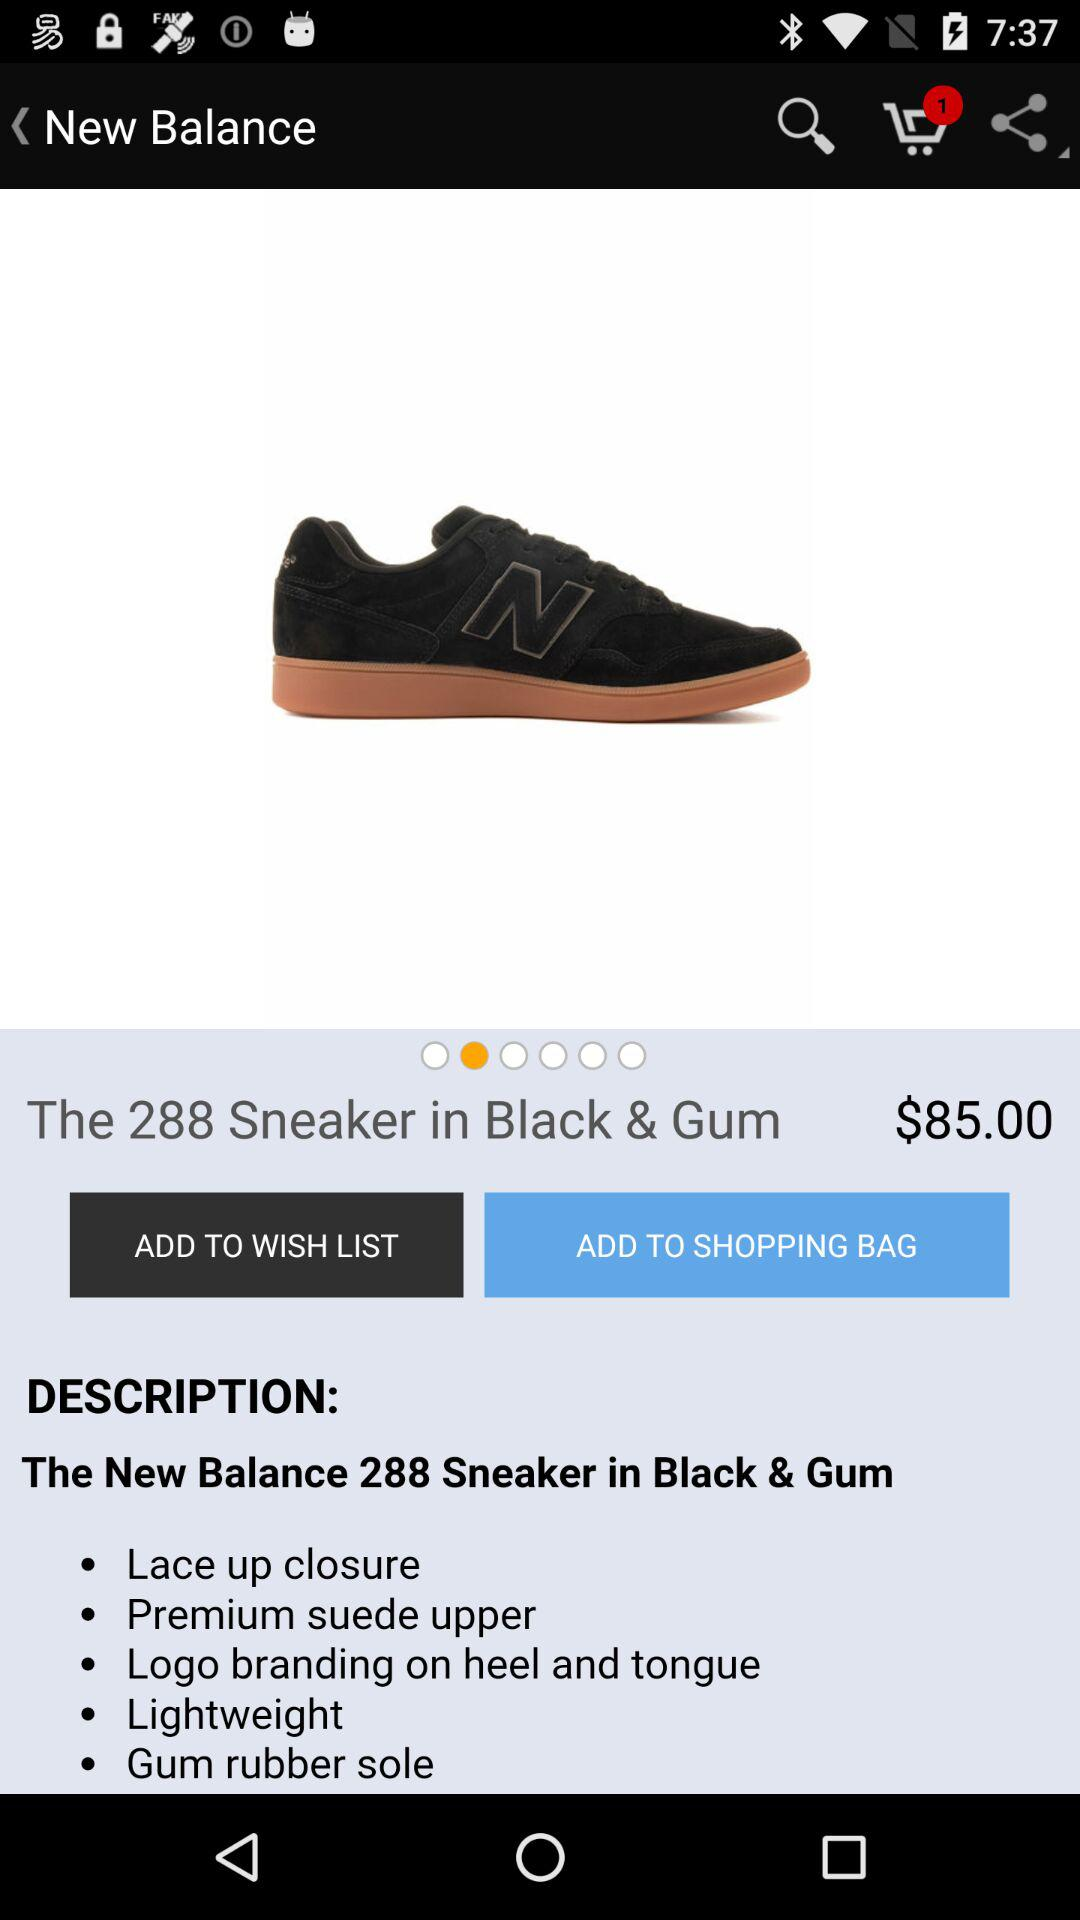How many more dollars is the price of the product than the number of items in the shopping cart?
Answer the question using a single word or phrase. 84 